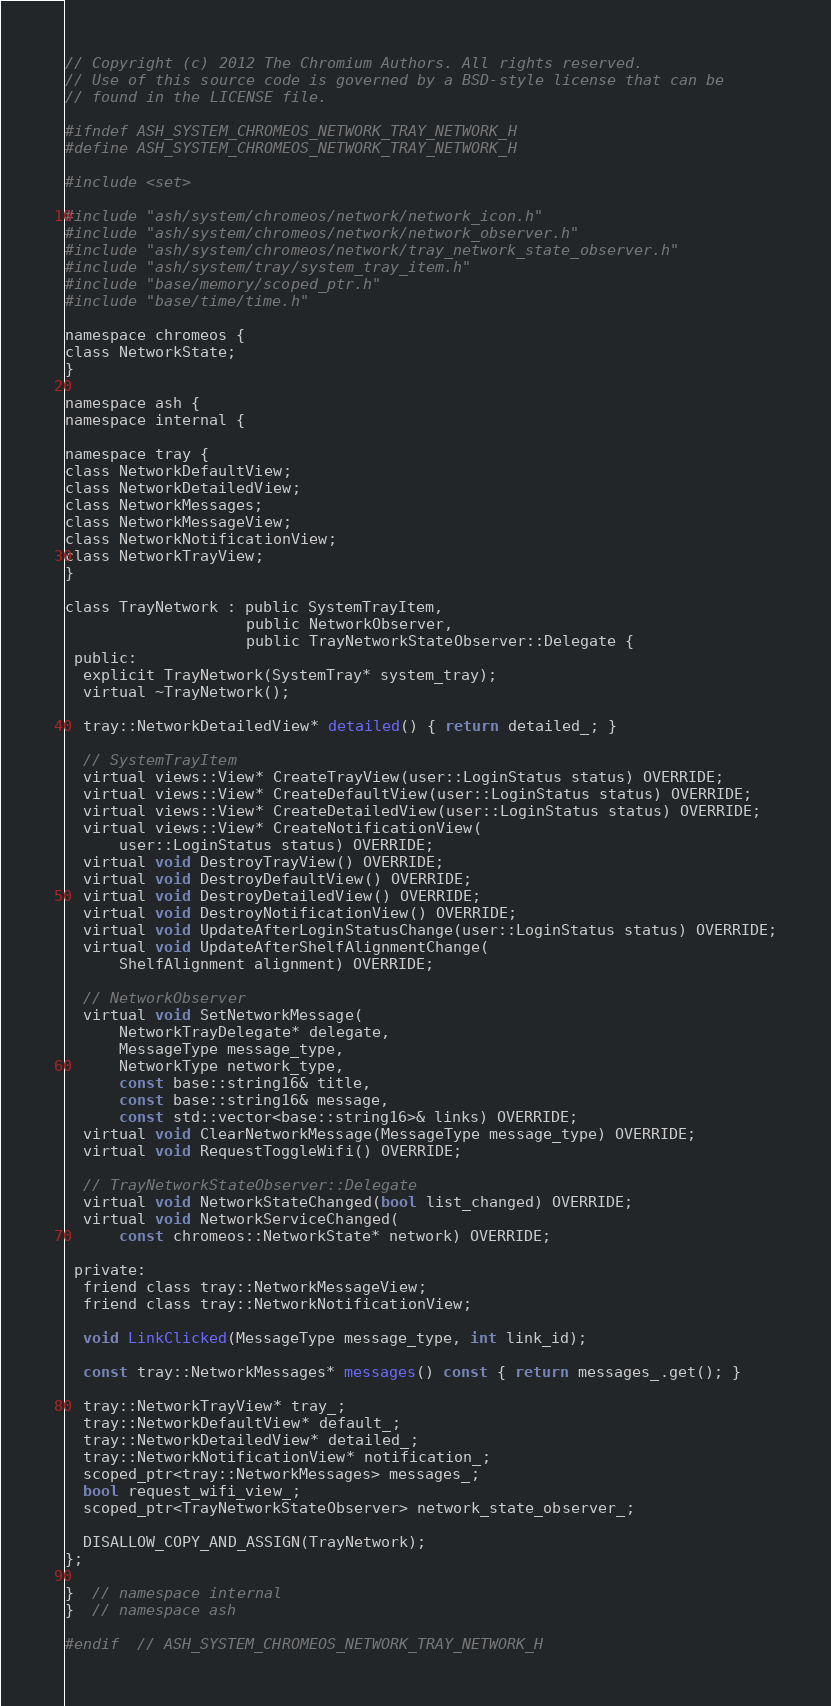<code> <loc_0><loc_0><loc_500><loc_500><_C_>// Copyright (c) 2012 The Chromium Authors. All rights reserved.
// Use of this source code is governed by a BSD-style license that can be
// found in the LICENSE file.

#ifndef ASH_SYSTEM_CHROMEOS_NETWORK_TRAY_NETWORK_H
#define ASH_SYSTEM_CHROMEOS_NETWORK_TRAY_NETWORK_H

#include <set>

#include "ash/system/chromeos/network/network_icon.h"
#include "ash/system/chromeos/network/network_observer.h"
#include "ash/system/chromeos/network/tray_network_state_observer.h"
#include "ash/system/tray/system_tray_item.h"
#include "base/memory/scoped_ptr.h"
#include "base/time/time.h"

namespace chromeos {
class NetworkState;
}

namespace ash {
namespace internal {

namespace tray {
class NetworkDefaultView;
class NetworkDetailedView;
class NetworkMessages;
class NetworkMessageView;
class NetworkNotificationView;
class NetworkTrayView;
}

class TrayNetwork : public SystemTrayItem,
                    public NetworkObserver,
                    public TrayNetworkStateObserver::Delegate {
 public:
  explicit TrayNetwork(SystemTray* system_tray);
  virtual ~TrayNetwork();

  tray::NetworkDetailedView* detailed() { return detailed_; }

  // SystemTrayItem
  virtual views::View* CreateTrayView(user::LoginStatus status) OVERRIDE;
  virtual views::View* CreateDefaultView(user::LoginStatus status) OVERRIDE;
  virtual views::View* CreateDetailedView(user::LoginStatus status) OVERRIDE;
  virtual views::View* CreateNotificationView(
      user::LoginStatus status) OVERRIDE;
  virtual void DestroyTrayView() OVERRIDE;
  virtual void DestroyDefaultView() OVERRIDE;
  virtual void DestroyDetailedView() OVERRIDE;
  virtual void DestroyNotificationView() OVERRIDE;
  virtual void UpdateAfterLoginStatusChange(user::LoginStatus status) OVERRIDE;
  virtual void UpdateAfterShelfAlignmentChange(
      ShelfAlignment alignment) OVERRIDE;

  // NetworkObserver
  virtual void SetNetworkMessage(
      NetworkTrayDelegate* delegate,
      MessageType message_type,
      NetworkType network_type,
      const base::string16& title,
      const base::string16& message,
      const std::vector<base::string16>& links) OVERRIDE;
  virtual void ClearNetworkMessage(MessageType message_type) OVERRIDE;
  virtual void RequestToggleWifi() OVERRIDE;

  // TrayNetworkStateObserver::Delegate
  virtual void NetworkStateChanged(bool list_changed) OVERRIDE;
  virtual void NetworkServiceChanged(
      const chromeos::NetworkState* network) OVERRIDE;

 private:
  friend class tray::NetworkMessageView;
  friend class tray::NetworkNotificationView;

  void LinkClicked(MessageType message_type, int link_id);

  const tray::NetworkMessages* messages() const { return messages_.get(); }

  tray::NetworkTrayView* tray_;
  tray::NetworkDefaultView* default_;
  tray::NetworkDetailedView* detailed_;
  tray::NetworkNotificationView* notification_;
  scoped_ptr<tray::NetworkMessages> messages_;
  bool request_wifi_view_;
  scoped_ptr<TrayNetworkStateObserver> network_state_observer_;

  DISALLOW_COPY_AND_ASSIGN(TrayNetwork);
};

}  // namespace internal
}  // namespace ash

#endif  // ASH_SYSTEM_CHROMEOS_NETWORK_TRAY_NETWORK_H
</code> 